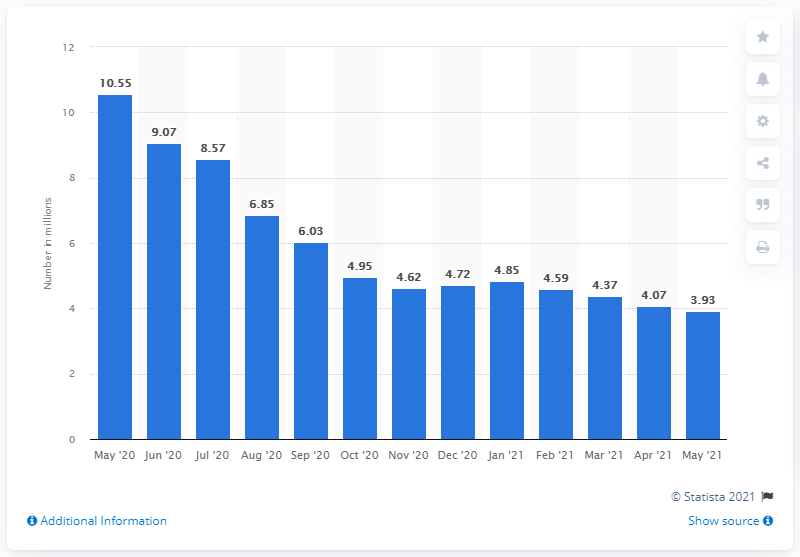Identify some key points in this picture. According to the latest data available as of May 2021, 3.93 million women were unemployed. In May 2020, there were 10.55 women who were unemployed. 